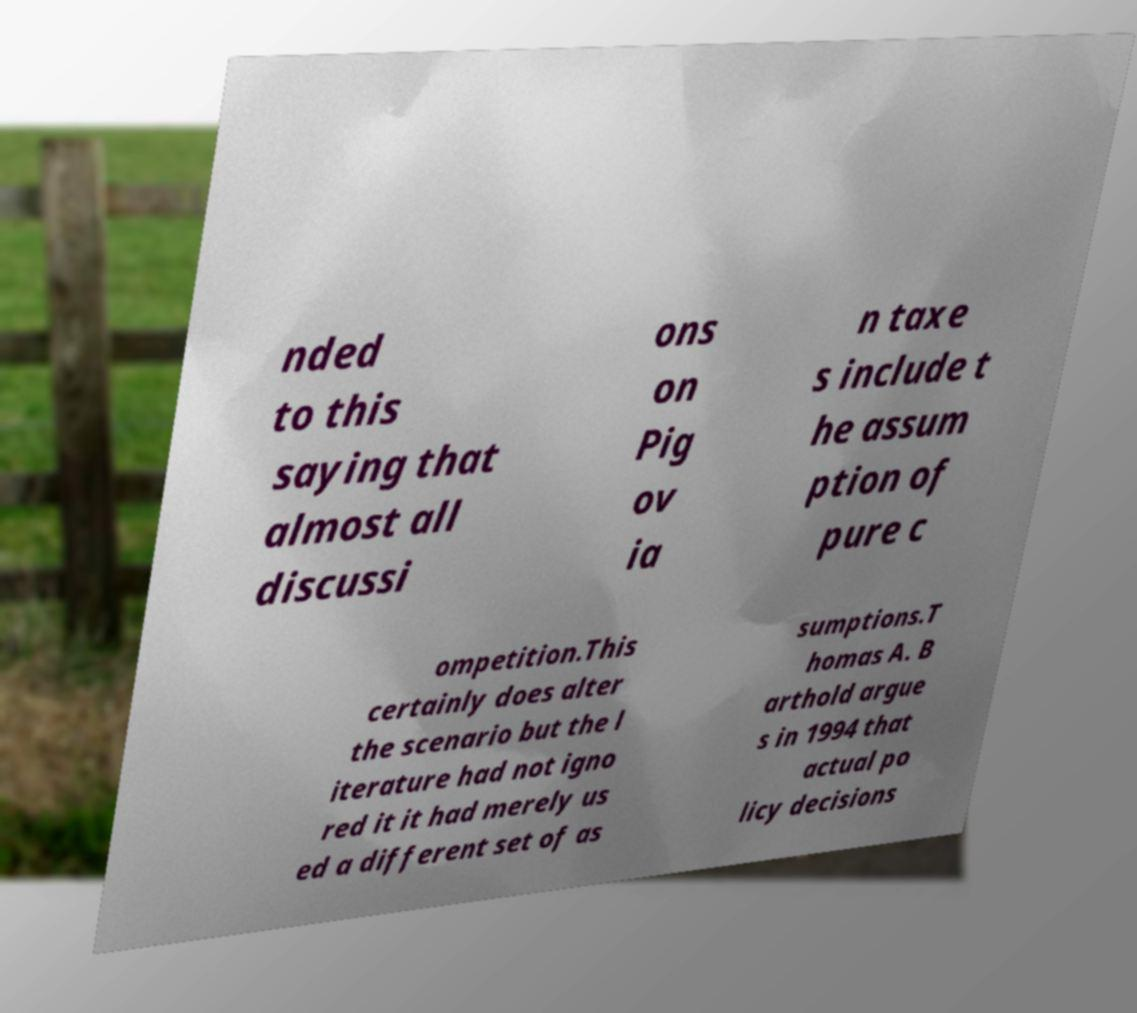Can you read and provide the text displayed in the image?This photo seems to have some interesting text. Can you extract and type it out for me? nded to this saying that almost all discussi ons on Pig ov ia n taxe s include t he assum ption of pure c ompetition.This certainly does alter the scenario but the l iterature had not igno red it it had merely us ed a different set of as sumptions.T homas A. B arthold argue s in 1994 that actual po licy decisions 